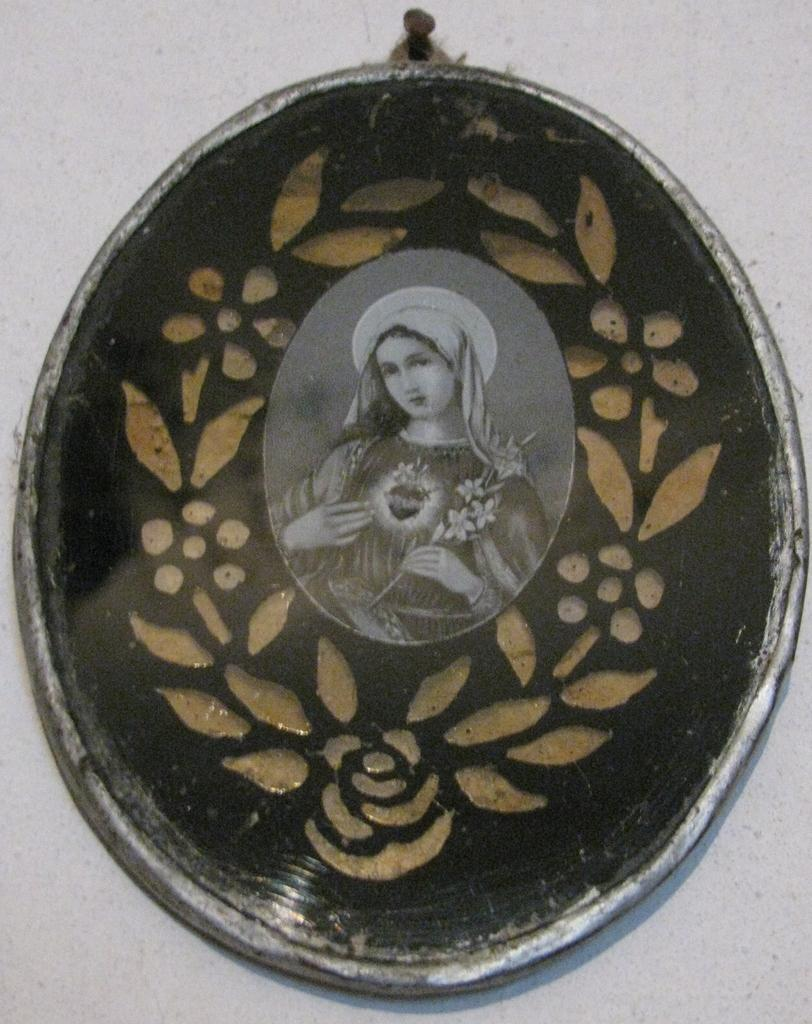What is attached to the wall in the image? There is a frame attached to the wall in the image. What can be seen inside the frame? There is a person visible in the frame. What is the color of the wall in the image? The wall is in white color. What type of breakfast is the person eating in the image? There is no breakfast visible in the image, as it only shows a frame with a person on a white wall. 